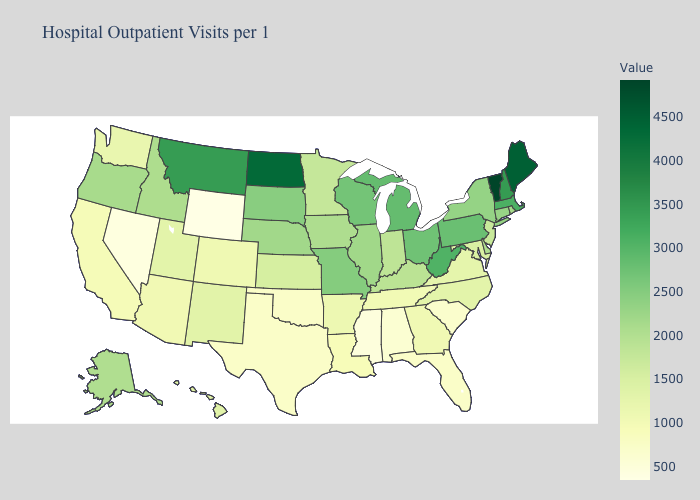Which states hav the highest value in the West?
Concise answer only. Montana. Among the states that border Arizona , which have the highest value?
Give a very brief answer. New Mexico. Which states have the highest value in the USA?
Concise answer only. Vermont. Does Oregon have a lower value than Michigan?
Concise answer only. Yes. Which states have the lowest value in the USA?
Quick response, please. Wyoming. Does Connecticut have a higher value than Minnesota?
Short answer required. Yes. 